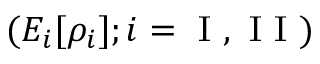<formula> <loc_0><loc_0><loc_500><loc_500>( E _ { i } [ \rho _ { i } ] ; i = I , I I )</formula> 